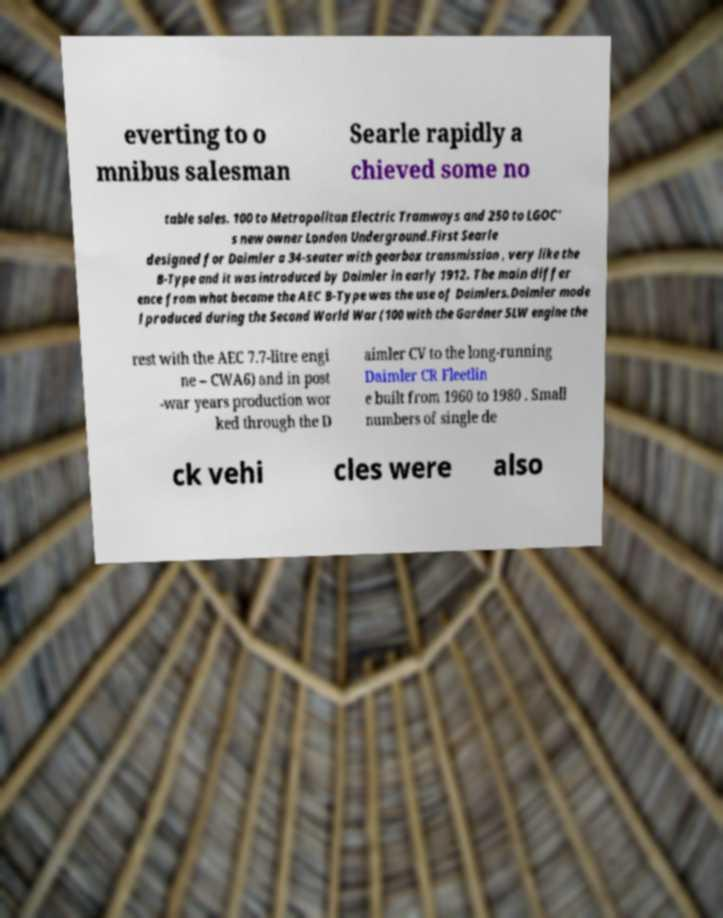For documentation purposes, I need the text within this image transcribed. Could you provide that? everting to o mnibus salesman Searle rapidly a chieved some no table sales. 100 to Metropolitan Electric Tramways and 250 to LGOC' s new owner London Underground.First Searle designed for Daimler a 34-seater with gearbox transmission , very like the B-Type and it was introduced by Daimler in early 1912. The main differ ence from what became the AEC B-Type was the use of Daimlers.Daimler mode l produced during the Second World War (100 with the Gardner 5LW engine the rest with the AEC 7.7-litre engi ne – CWA6) and in post -war years production wor ked through the D aimler CV to the long-running Daimler CR Fleetlin e built from 1960 to 1980 . Small numbers of single de ck vehi cles were also 